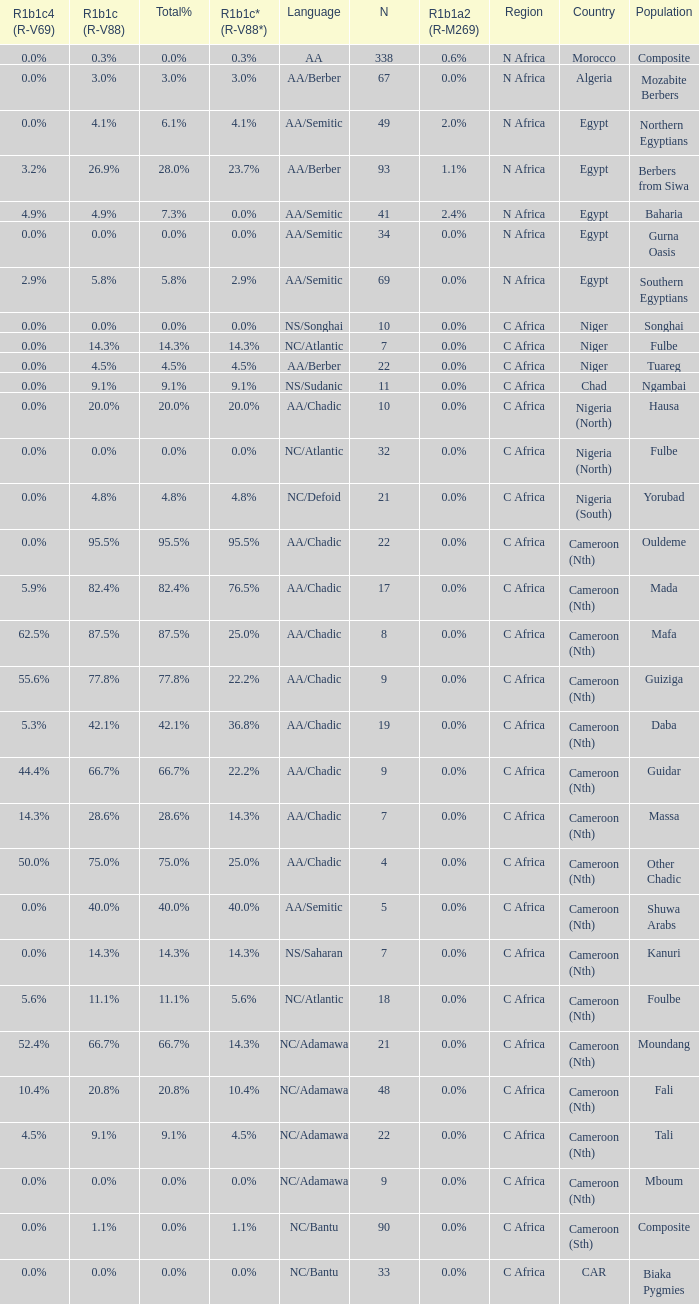What percentage is listed in column r1b1c (r-v88) for the 4.5% total percentage? 4.5%. 